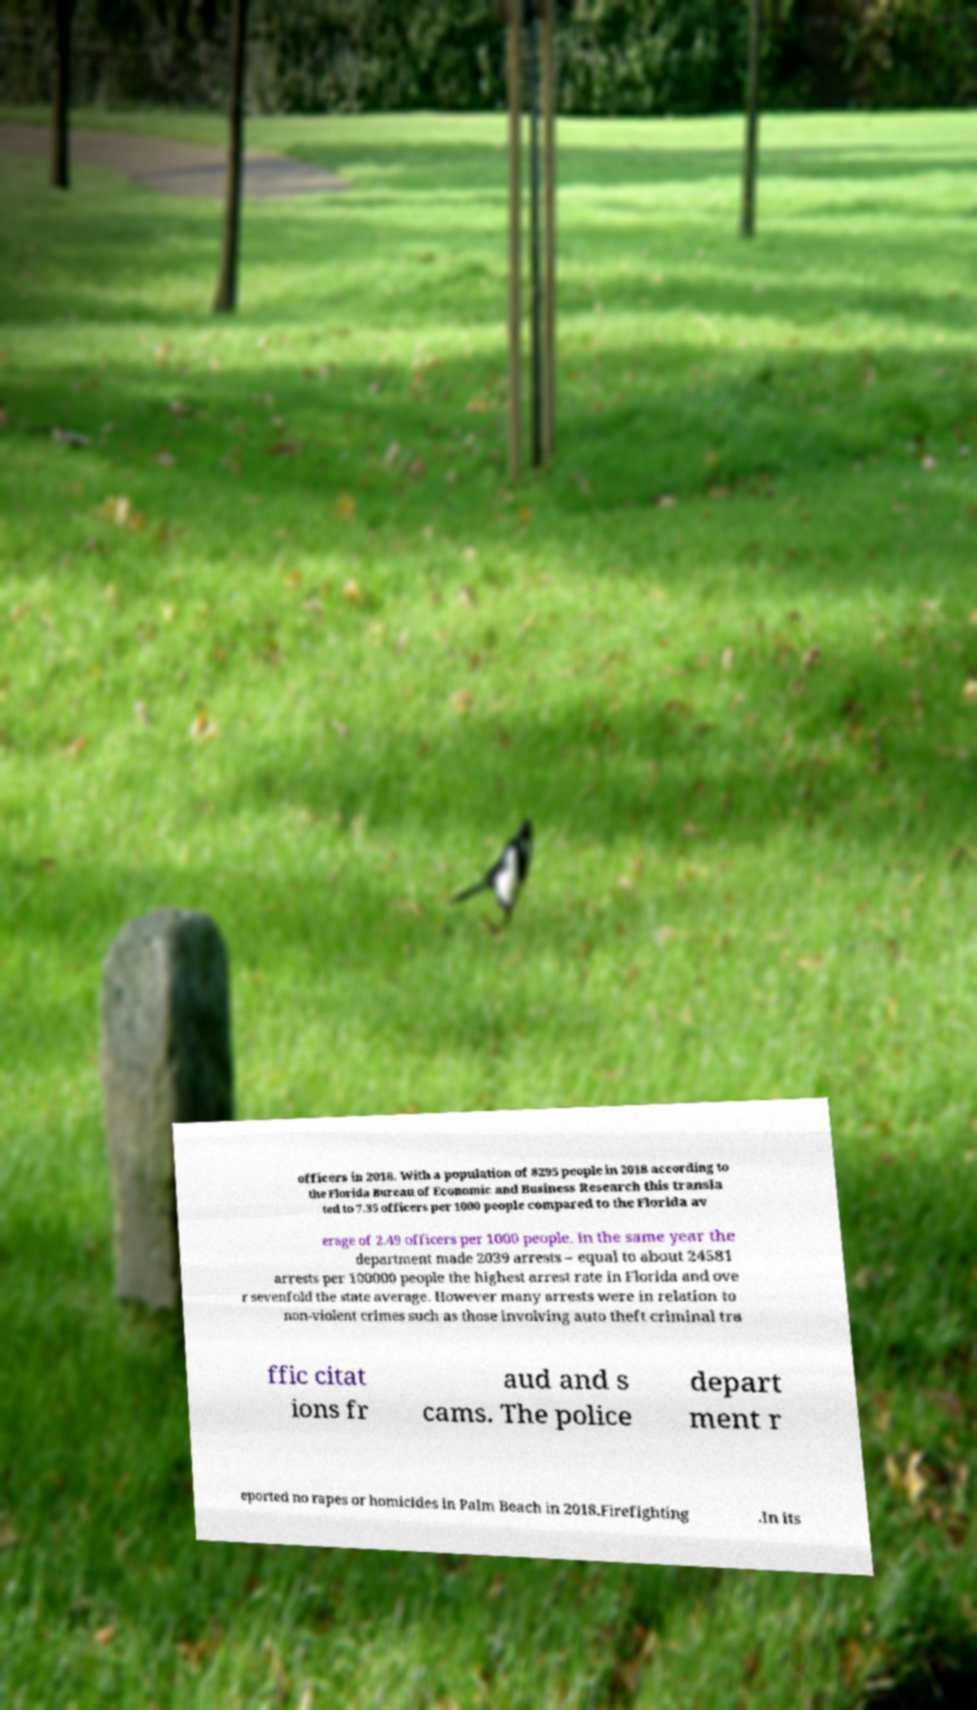Please read and relay the text visible in this image. What does it say? officers in 2018. With a population of 8295 people in 2018 according to the Florida Bureau of Economic and Business Research this transla ted to 7.35 officers per 1000 people compared to the Florida av erage of 2.49 officers per 1000 people. In the same year the department made 2039 arrests – equal to about 24581 arrests per 100000 people the highest arrest rate in Florida and ove r sevenfold the state average. However many arrests were in relation to non-violent crimes such as those involving auto theft criminal tra ffic citat ions fr aud and s cams. The police depart ment r eported no rapes or homicides in Palm Beach in 2018.Firefighting .In its 